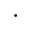<formula> <loc_0><loc_0><loc_500><loc_500>\cdot</formula> 